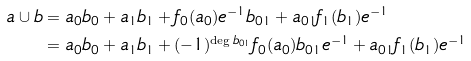Convert formula to latex. <formula><loc_0><loc_0><loc_500><loc_500>a \cup b & = a _ { 0 } b _ { 0 } + a _ { 1 } b _ { 1 } + f _ { 0 } ( a _ { 0 } ) e ^ { - 1 } b _ { 0 1 } + a _ { 0 1 } f _ { 1 } ( b _ { 1 } ) e ^ { - 1 } \\ & = a _ { 0 } b _ { 0 } + a _ { 1 } b _ { 1 } + ( - 1 ) ^ { \deg b _ { 0 1 } } f _ { 0 } ( a _ { 0 } ) b _ { 0 1 } e ^ { - 1 } + a _ { 0 1 } f _ { 1 } ( b _ { 1 } ) e ^ { - 1 }</formula> 